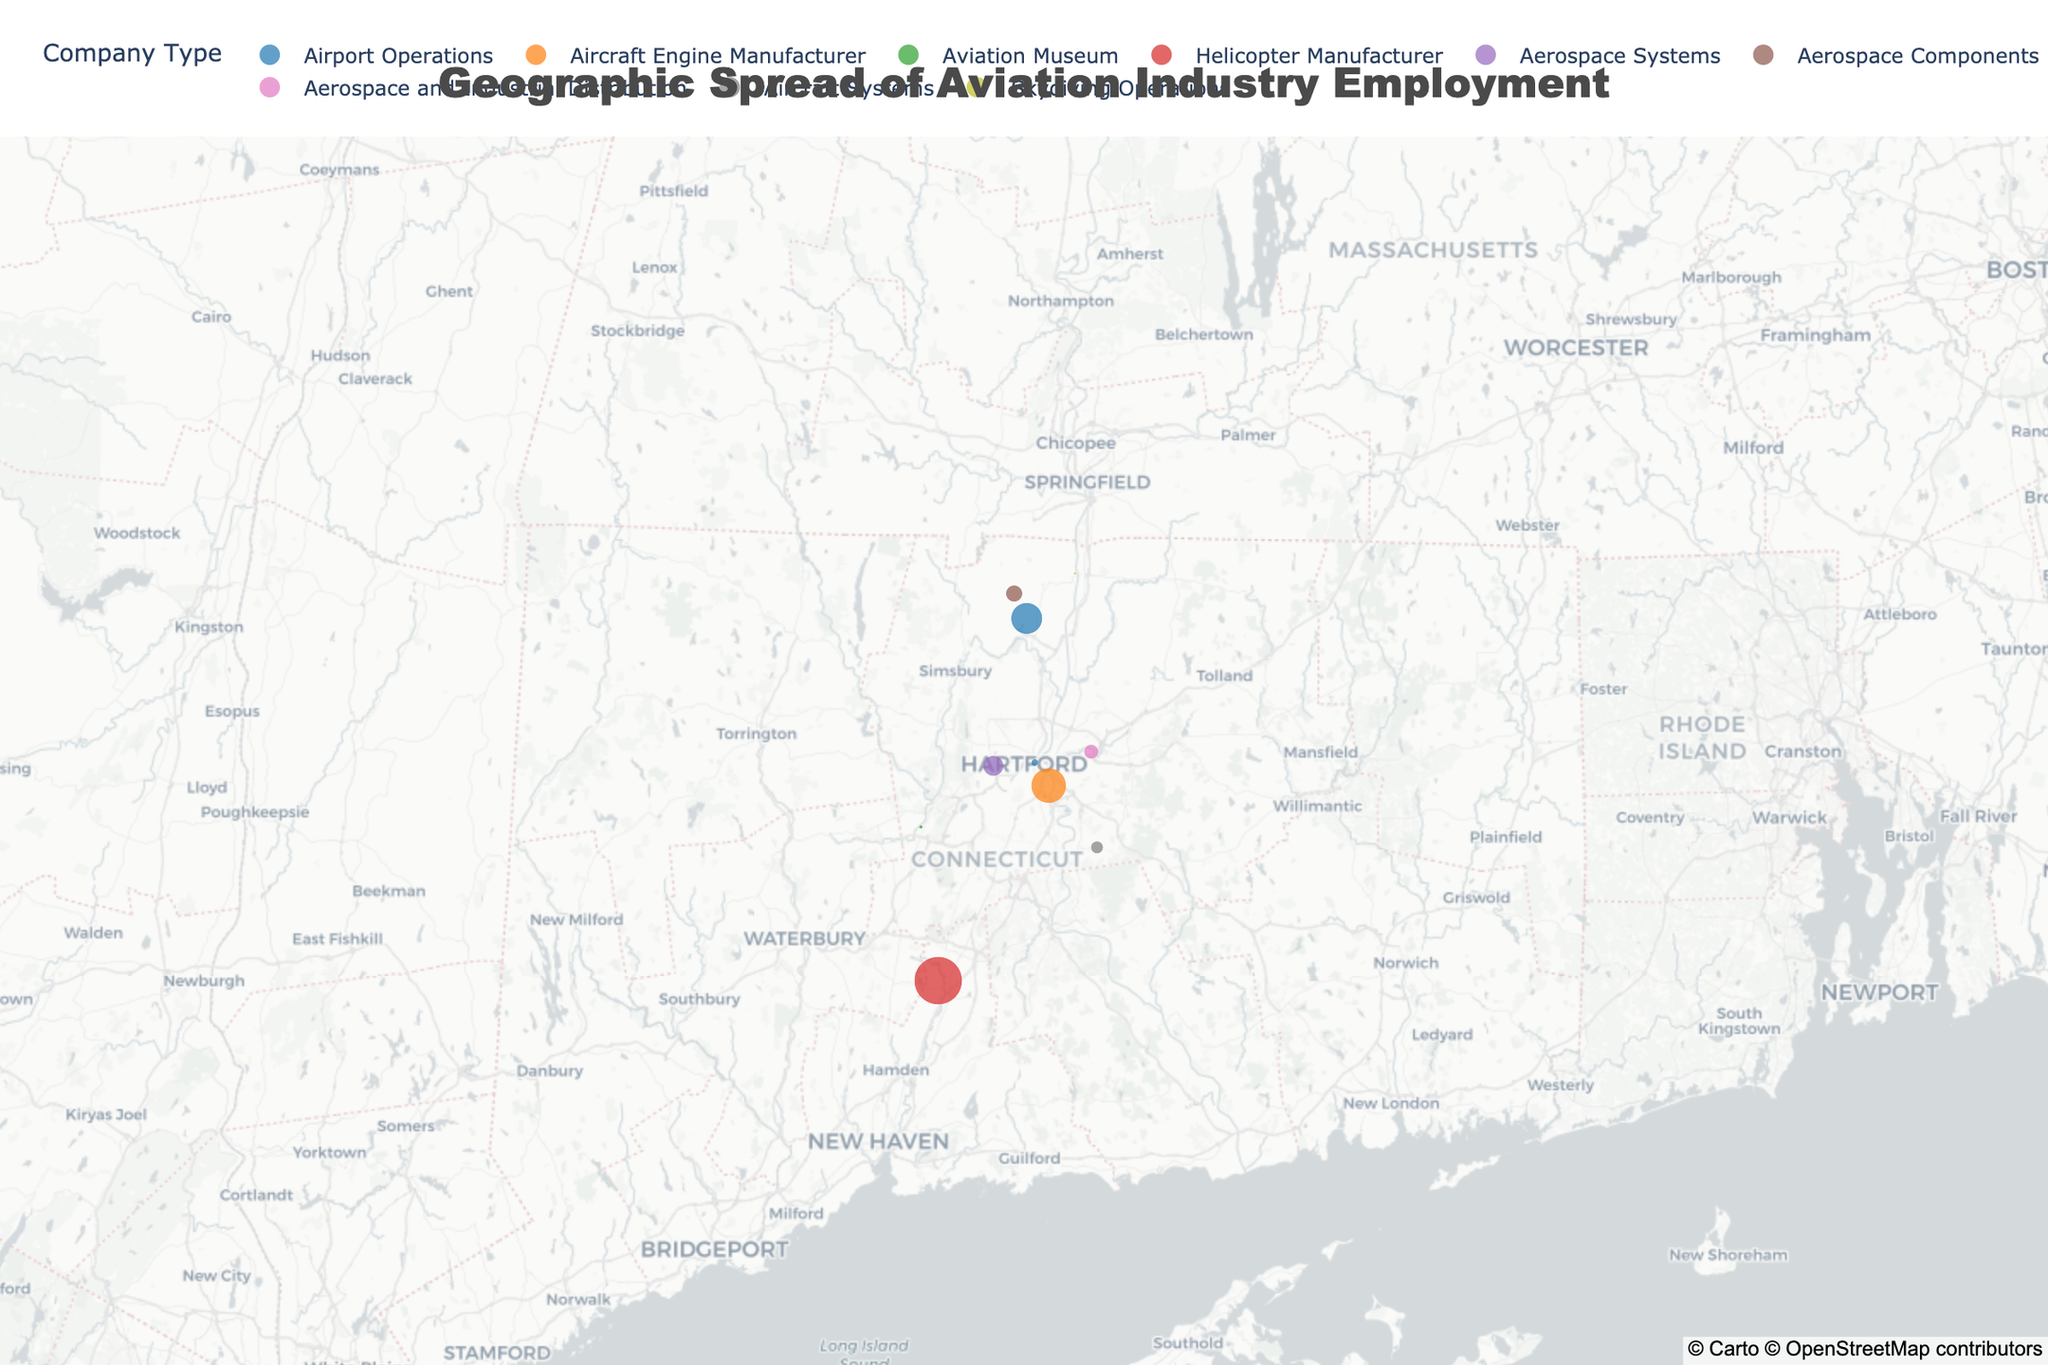What's the title of the figure? The title appears at the top of the map and provides an overview of what the figure represents.
Answer: Geographic Spread of Aviation Industry Employment How many locations are shown on the map? Each point on the map represents a location, so counting the points will give the number of locations.
Answer: 10 Which company has the highest employee count? Looking at the size of the circles on the map, the largest circles represent the companies with the highest employee count.
Answer: Sikorsky Aircraft Corporation What is the average employee count for the Aviation Museum and Skydiving Operations? Sum the employee counts of the Aviation Museum (45) and Skydiving Operations (25), then divide by 2. (45 + 25) / 2 = 35.
Answer: 35 Which company type is shown with the most diversity in locations? Count the number of distinct locations for each company type based on color and hover information. "Aerospace Systems" and others may have multiple distinct locations.
Answer: Airport Operations Are the majority of the companies located north or south of the center point of the map? Determine the map's center point using the average latitude (around 41.75), then compare it with individual latitudes. Most points are below 41.75.
Answer: South Which two companies are closest to each other geographically? Visually identify the closest points on the map and check their names using the hover information.
Answer: Hartford-Brainard Airport and Pratt & Whitney Headquarters How many unique company types are displayed on the map? Each unique color represents a different company type. Count the different colors in the legend.
Answer: 10 Which specific area has the highest concentration of aviation-related employment? Look for the area with the most points and/or largest circles, giving a high concentration of employment. The area around Sikorsky Aircraft Corporation and Pratt & Whitney Headquarters has large circles.
Answer: Sikorsky Aircraft Corporation area 